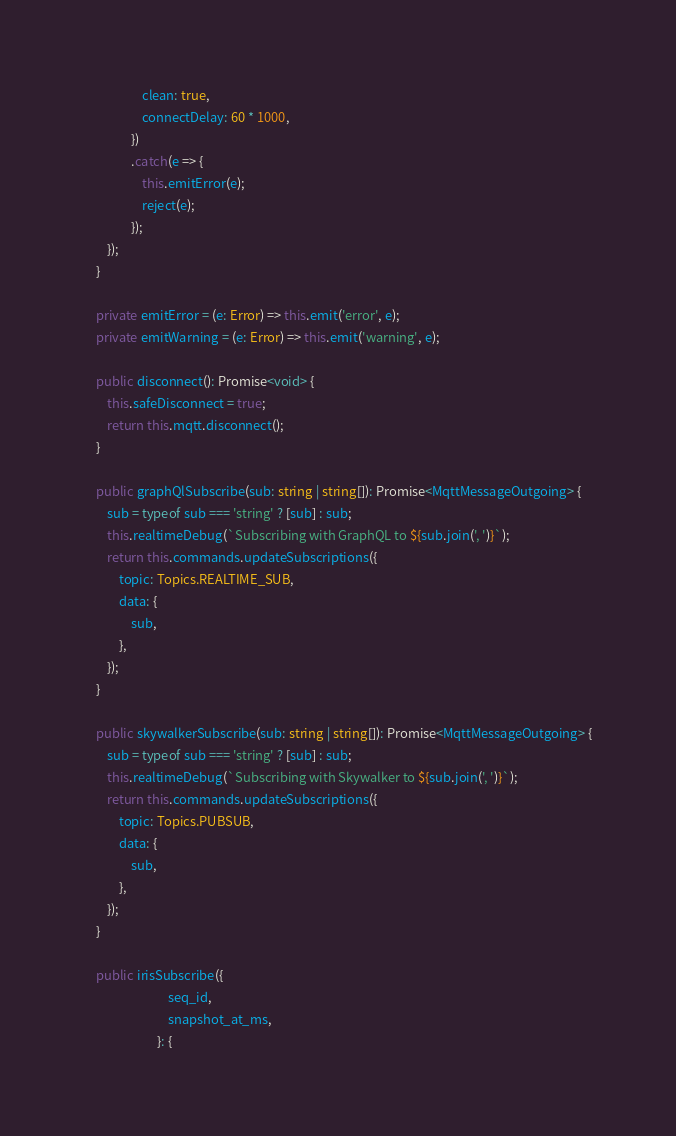<code> <loc_0><loc_0><loc_500><loc_500><_TypeScript_>                    clean: true,
                    connectDelay: 60 * 1000,
                })
                .catch(e => {
                    this.emitError(e);
                    reject(e);
                });
        });
    }

    private emitError = (e: Error) => this.emit('error', e);
    private emitWarning = (e: Error) => this.emit('warning', e);

    public disconnect(): Promise<void> {
        this.safeDisconnect = true;
        return this.mqtt.disconnect();
    }

    public graphQlSubscribe(sub: string | string[]): Promise<MqttMessageOutgoing> {
        sub = typeof sub === 'string' ? [sub] : sub;
        this.realtimeDebug(`Subscribing with GraphQL to ${sub.join(', ')}`);
        return this.commands.updateSubscriptions({
            topic: Topics.REALTIME_SUB,
            data: {
                sub,
            },
        });
    }

    public skywalkerSubscribe(sub: string | string[]): Promise<MqttMessageOutgoing> {
        sub = typeof sub === 'string' ? [sub] : sub;
        this.realtimeDebug(`Subscribing with Skywalker to ${sub.join(', ')}`);
        return this.commands.updateSubscriptions({
            topic: Topics.PUBSUB,
            data: {
                sub,
            },
        });
    }

    public irisSubscribe({
                             seq_id,
                             snapshot_at_ms,
                         }: {</code> 